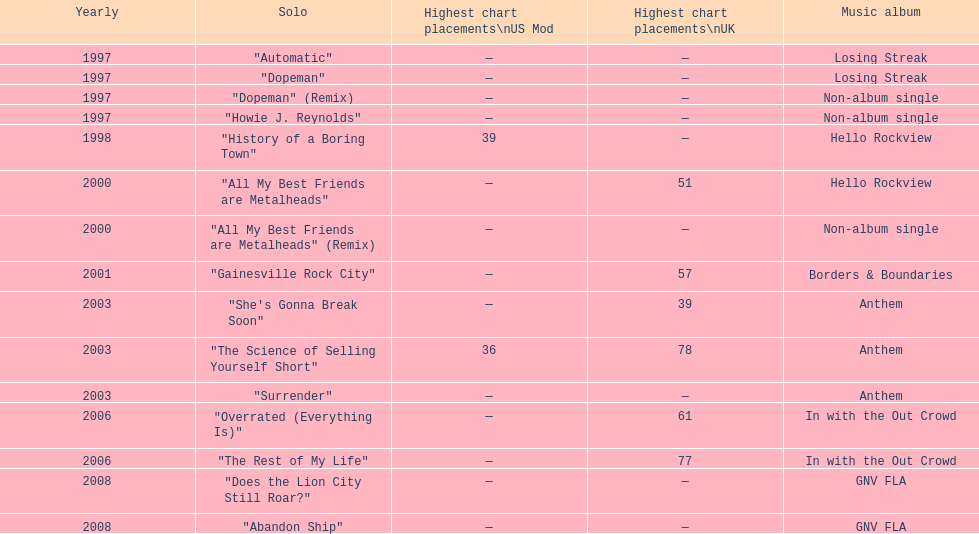Which album had the single automatic? Losing Streak. 